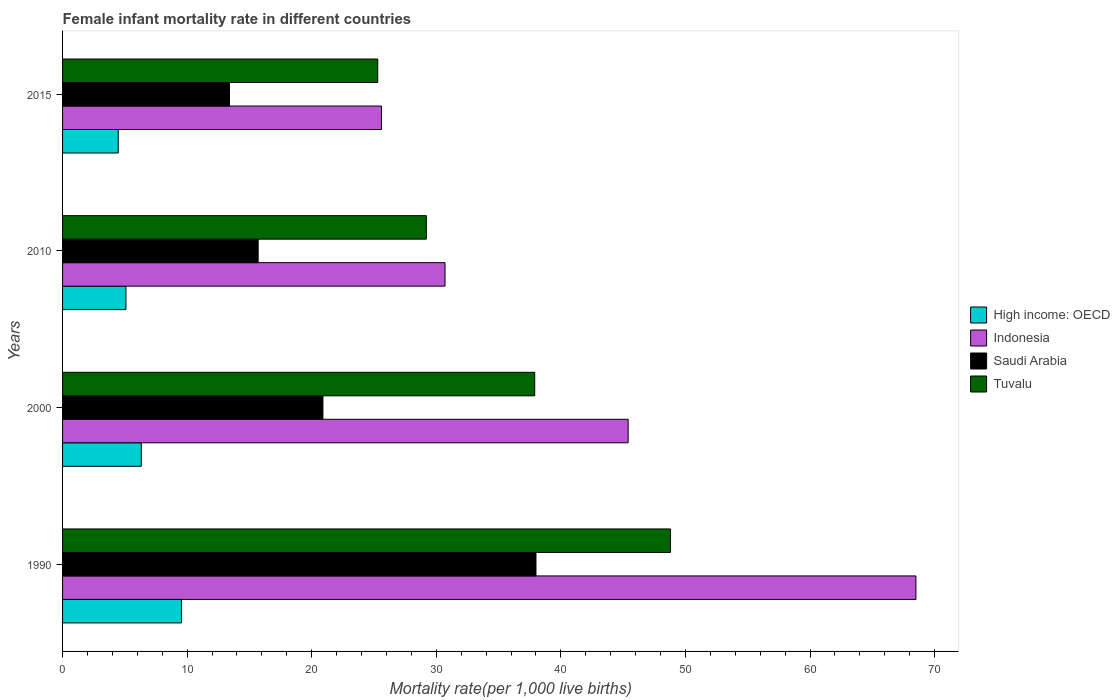How many groups of bars are there?
Ensure brevity in your answer.  4. Are the number of bars on each tick of the Y-axis equal?
Offer a very short reply. Yes. How many bars are there on the 1st tick from the bottom?
Your answer should be compact. 4. What is the label of the 3rd group of bars from the top?
Give a very brief answer. 2000. What is the female infant mortality rate in High income: OECD in 2010?
Your response must be concise. 5.09. Across all years, what is the maximum female infant mortality rate in Tuvalu?
Provide a succinct answer. 48.8. Across all years, what is the minimum female infant mortality rate in Indonesia?
Offer a terse response. 25.6. In which year was the female infant mortality rate in Tuvalu maximum?
Provide a short and direct response. 1990. In which year was the female infant mortality rate in Saudi Arabia minimum?
Ensure brevity in your answer.  2015. What is the difference between the female infant mortality rate in Saudi Arabia in 1990 and that in 2010?
Your response must be concise. 22.3. What is the difference between the female infant mortality rate in Indonesia in 2010 and the female infant mortality rate in High income: OECD in 2015?
Your answer should be very brief. 26.23. What is the average female infant mortality rate in High income: OECD per year?
Your answer should be very brief. 6.36. In the year 2015, what is the difference between the female infant mortality rate in Indonesia and female infant mortality rate in Saudi Arabia?
Your answer should be very brief. 12.2. In how many years, is the female infant mortality rate in High income: OECD greater than 56 ?
Provide a short and direct response. 0. What is the ratio of the female infant mortality rate in High income: OECD in 2000 to that in 2015?
Offer a terse response. 1.41. Is the female infant mortality rate in Tuvalu in 2000 less than that in 2010?
Keep it short and to the point. No. Is the difference between the female infant mortality rate in Indonesia in 1990 and 2000 greater than the difference between the female infant mortality rate in Saudi Arabia in 1990 and 2000?
Keep it short and to the point. Yes. What is the difference between the highest and the second highest female infant mortality rate in Indonesia?
Keep it short and to the point. 23.1. What is the difference between the highest and the lowest female infant mortality rate in High income: OECD?
Make the answer very short. 5.07. What does the 4th bar from the top in 2015 represents?
Offer a very short reply. High income: OECD. What does the 3rd bar from the bottom in 2000 represents?
Make the answer very short. Saudi Arabia. How many bars are there?
Ensure brevity in your answer.  16. Does the graph contain any zero values?
Provide a succinct answer. No. Where does the legend appear in the graph?
Your response must be concise. Center right. How are the legend labels stacked?
Offer a very short reply. Vertical. What is the title of the graph?
Your answer should be very brief. Female infant mortality rate in different countries. What is the label or title of the X-axis?
Provide a short and direct response. Mortality rate(per 1,0 live births). What is the label or title of the Y-axis?
Ensure brevity in your answer.  Years. What is the Mortality rate(per 1,000 live births) of High income: OECD in 1990?
Your response must be concise. 9.54. What is the Mortality rate(per 1,000 live births) in Indonesia in 1990?
Your answer should be compact. 68.5. What is the Mortality rate(per 1,000 live births) of Saudi Arabia in 1990?
Your answer should be very brief. 38. What is the Mortality rate(per 1,000 live births) in Tuvalu in 1990?
Keep it short and to the point. 48.8. What is the Mortality rate(per 1,000 live births) of High income: OECD in 2000?
Your answer should be compact. 6.32. What is the Mortality rate(per 1,000 live births) in Indonesia in 2000?
Your answer should be very brief. 45.4. What is the Mortality rate(per 1,000 live births) of Saudi Arabia in 2000?
Your response must be concise. 20.9. What is the Mortality rate(per 1,000 live births) in Tuvalu in 2000?
Give a very brief answer. 37.9. What is the Mortality rate(per 1,000 live births) in High income: OECD in 2010?
Offer a very short reply. 5.09. What is the Mortality rate(per 1,000 live births) of Indonesia in 2010?
Offer a terse response. 30.7. What is the Mortality rate(per 1,000 live births) of Tuvalu in 2010?
Your response must be concise. 29.2. What is the Mortality rate(per 1,000 live births) of High income: OECD in 2015?
Your answer should be very brief. 4.47. What is the Mortality rate(per 1,000 live births) in Indonesia in 2015?
Provide a short and direct response. 25.6. What is the Mortality rate(per 1,000 live births) in Saudi Arabia in 2015?
Keep it short and to the point. 13.4. What is the Mortality rate(per 1,000 live births) in Tuvalu in 2015?
Your answer should be compact. 25.3. Across all years, what is the maximum Mortality rate(per 1,000 live births) of High income: OECD?
Give a very brief answer. 9.54. Across all years, what is the maximum Mortality rate(per 1,000 live births) of Indonesia?
Offer a terse response. 68.5. Across all years, what is the maximum Mortality rate(per 1,000 live births) in Saudi Arabia?
Provide a short and direct response. 38. Across all years, what is the maximum Mortality rate(per 1,000 live births) of Tuvalu?
Offer a terse response. 48.8. Across all years, what is the minimum Mortality rate(per 1,000 live births) of High income: OECD?
Your answer should be very brief. 4.47. Across all years, what is the minimum Mortality rate(per 1,000 live births) in Indonesia?
Provide a short and direct response. 25.6. Across all years, what is the minimum Mortality rate(per 1,000 live births) in Tuvalu?
Provide a succinct answer. 25.3. What is the total Mortality rate(per 1,000 live births) in High income: OECD in the graph?
Your answer should be very brief. 25.42. What is the total Mortality rate(per 1,000 live births) in Indonesia in the graph?
Give a very brief answer. 170.2. What is the total Mortality rate(per 1,000 live births) of Tuvalu in the graph?
Offer a terse response. 141.2. What is the difference between the Mortality rate(per 1,000 live births) of High income: OECD in 1990 and that in 2000?
Your answer should be compact. 3.22. What is the difference between the Mortality rate(per 1,000 live births) in Indonesia in 1990 and that in 2000?
Your answer should be very brief. 23.1. What is the difference between the Mortality rate(per 1,000 live births) in High income: OECD in 1990 and that in 2010?
Provide a short and direct response. 4.45. What is the difference between the Mortality rate(per 1,000 live births) in Indonesia in 1990 and that in 2010?
Ensure brevity in your answer.  37.8. What is the difference between the Mortality rate(per 1,000 live births) in Saudi Arabia in 1990 and that in 2010?
Your response must be concise. 22.3. What is the difference between the Mortality rate(per 1,000 live births) in Tuvalu in 1990 and that in 2010?
Give a very brief answer. 19.6. What is the difference between the Mortality rate(per 1,000 live births) in High income: OECD in 1990 and that in 2015?
Keep it short and to the point. 5.07. What is the difference between the Mortality rate(per 1,000 live births) of Indonesia in 1990 and that in 2015?
Offer a very short reply. 42.9. What is the difference between the Mortality rate(per 1,000 live births) of Saudi Arabia in 1990 and that in 2015?
Keep it short and to the point. 24.6. What is the difference between the Mortality rate(per 1,000 live births) of High income: OECD in 2000 and that in 2010?
Your answer should be very brief. 1.23. What is the difference between the Mortality rate(per 1,000 live births) of Tuvalu in 2000 and that in 2010?
Make the answer very short. 8.7. What is the difference between the Mortality rate(per 1,000 live births) in High income: OECD in 2000 and that in 2015?
Your answer should be very brief. 1.85. What is the difference between the Mortality rate(per 1,000 live births) of Indonesia in 2000 and that in 2015?
Your answer should be very brief. 19.8. What is the difference between the Mortality rate(per 1,000 live births) of Saudi Arabia in 2000 and that in 2015?
Your response must be concise. 7.5. What is the difference between the Mortality rate(per 1,000 live births) in Tuvalu in 2000 and that in 2015?
Offer a terse response. 12.6. What is the difference between the Mortality rate(per 1,000 live births) in High income: OECD in 2010 and that in 2015?
Give a very brief answer. 0.62. What is the difference between the Mortality rate(per 1,000 live births) of Tuvalu in 2010 and that in 2015?
Keep it short and to the point. 3.9. What is the difference between the Mortality rate(per 1,000 live births) of High income: OECD in 1990 and the Mortality rate(per 1,000 live births) of Indonesia in 2000?
Offer a very short reply. -35.86. What is the difference between the Mortality rate(per 1,000 live births) in High income: OECD in 1990 and the Mortality rate(per 1,000 live births) in Saudi Arabia in 2000?
Offer a very short reply. -11.36. What is the difference between the Mortality rate(per 1,000 live births) in High income: OECD in 1990 and the Mortality rate(per 1,000 live births) in Tuvalu in 2000?
Keep it short and to the point. -28.36. What is the difference between the Mortality rate(per 1,000 live births) of Indonesia in 1990 and the Mortality rate(per 1,000 live births) of Saudi Arabia in 2000?
Keep it short and to the point. 47.6. What is the difference between the Mortality rate(per 1,000 live births) in Indonesia in 1990 and the Mortality rate(per 1,000 live births) in Tuvalu in 2000?
Your answer should be very brief. 30.6. What is the difference between the Mortality rate(per 1,000 live births) in High income: OECD in 1990 and the Mortality rate(per 1,000 live births) in Indonesia in 2010?
Provide a succinct answer. -21.16. What is the difference between the Mortality rate(per 1,000 live births) of High income: OECD in 1990 and the Mortality rate(per 1,000 live births) of Saudi Arabia in 2010?
Keep it short and to the point. -6.16. What is the difference between the Mortality rate(per 1,000 live births) of High income: OECD in 1990 and the Mortality rate(per 1,000 live births) of Tuvalu in 2010?
Your answer should be compact. -19.66. What is the difference between the Mortality rate(per 1,000 live births) in Indonesia in 1990 and the Mortality rate(per 1,000 live births) in Saudi Arabia in 2010?
Your answer should be very brief. 52.8. What is the difference between the Mortality rate(per 1,000 live births) in Indonesia in 1990 and the Mortality rate(per 1,000 live births) in Tuvalu in 2010?
Offer a terse response. 39.3. What is the difference between the Mortality rate(per 1,000 live births) of Saudi Arabia in 1990 and the Mortality rate(per 1,000 live births) of Tuvalu in 2010?
Offer a terse response. 8.8. What is the difference between the Mortality rate(per 1,000 live births) of High income: OECD in 1990 and the Mortality rate(per 1,000 live births) of Indonesia in 2015?
Offer a very short reply. -16.06. What is the difference between the Mortality rate(per 1,000 live births) in High income: OECD in 1990 and the Mortality rate(per 1,000 live births) in Saudi Arabia in 2015?
Offer a very short reply. -3.86. What is the difference between the Mortality rate(per 1,000 live births) of High income: OECD in 1990 and the Mortality rate(per 1,000 live births) of Tuvalu in 2015?
Ensure brevity in your answer.  -15.76. What is the difference between the Mortality rate(per 1,000 live births) in Indonesia in 1990 and the Mortality rate(per 1,000 live births) in Saudi Arabia in 2015?
Make the answer very short. 55.1. What is the difference between the Mortality rate(per 1,000 live births) in Indonesia in 1990 and the Mortality rate(per 1,000 live births) in Tuvalu in 2015?
Ensure brevity in your answer.  43.2. What is the difference between the Mortality rate(per 1,000 live births) in High income: OECD in 2000 and the Mortality rate(per 1,000 live births) in Indonesia in 2010?
Provide a succinct answer. -24.38. What is the difference between the Mortality rate(per 1,000 live births) of High income: OECD in 2000 and the Mortality rate(per 1,000 live births) of Saudi Arabia in 2010?
Offer a terse response. -9.38. What is the difference between the Mortality rate(per 1,000 live births) in High income: OECD in 2000 and the Mortality rate(per 1,000 live births) in Tuvalu in 2010?
Offer a very short reply. -22.88. What is the difference between the Mortality rate(per 1,000 live births) in Indonesia in 2000 and the Mortality rate(per 1,000 live births) in Saudi Arabia in 2010?
Keep it short and to the point. 29.7. What is the difference between the Mortality rate(per 1,000 live births) of High income: OECD in 2000 and the Mortality rate(per 1,000 live births) of Indonesia in 2015?
Keep it short and to the point. -19.28. What is the difference between the Mortality rate(per 1,000 live births) of High income: OECD in 2000 and the Mortality rate(per 1,000 live births) of Saudi Arabia in 2015?
Make the answer very short. -7.08. What is the difference between the Mortality rate(per 1,000 live births) in High income: OECD in 2000 and the Mortality rate(per 1,000 live births) in Tuvalu in 2015?
Your answer should be compact. -18.98. What is the difference between the Mortality rate(per 1,000 live births) of Indonesia in 2000 and the Mortality rate(per 1,000 live births) of Saudi Arabia in 2015?
Provide a succinct answer. 32. What is the difference between the Mortality rate(per 1,000 live births) of Indonesia in 2000 and the Mortality rate(per 1,000 live births) of Tuvalu in 2015?
Offer a very short reply. 20.1. What is the difference between the Mortality rate(per 1,000 live births) in Saudi Arabia in 2000 and the Mortality rate(per 1,000 live births) in Tuvalu in 2015?
Offer a terse response. -4.4. What is the difference between the Mortality rate(per 1,000 live births) in High income: OECD in 2010 and the Mortality rate(per 1,000 live births) in Indonesia in 2015?
Offer a very short reply. -20.51. What is the difference between the Mortality rate(per 1,000 live births) in High income: OECD in 2010 and the Mortality rate(per 1,000 live births) in Saudi Arabia in 2015?
Your answer should be very brief. -8.31. What is the difference between the Mortality rate(per 1,000 live births) of High income: OECD in 2010 and the Mortality rate(per 1,000 live births) of Tuvalu in 2015?
Provide a succinct answer. -20.21. What is the difference between the Mortality rate(per 1,000 live births) of Indonesia in 2010 and the Mortality rate(per 1,000 live births) of Tuvalu in 2015?
Your answer should be compact. 5.4. What is the difference between the Mortality rate(per 1,000 live births) of Saudi Arabia in 2010 and the Mortality rate(per 1,000 live births) of Tuvalu in 2015?
Provide a short and direct response. -9.6. What is the average Mortality rate(per 1,000 live births) of High income: OECD per year?
Keep it short and to the point. 6.36. What is the average Mortality rate(per 1,000 live births) of Indonesia per year?
Ensure brevity in your answer.  42.55. What is the average Mortality rate(per 1,000 live births) of Tuvalu per year?
Offer a terse response. 35.3. In the year 1990, what is the difference between the Mortality rate(per 1,000 live births) in High income: OECD and Mortality rate(per 1,000 live births) in Indonesia?
Keep it short and to the point. -58.96. In the year 1990, what is the difference between the Mortality rate(per 1,000 live births) in High income: OECD and Mortality rate(per 1,000 live births) in Saudi Arabia?
Your answer should be compact. -28.46. In the year 1990, what is the difference between the Mortality rate(per 1,000 live births) in High income: OECD and Mortality rate(per 1,000 live births) in Tuvalu?
Offer a very short reply. -39.26. In the year 1990, what is the difference between the Mortality rate(per 1,000 live births) of Indonesia and Mortality rate(per 1,000 live births) of Saudi Arabia?
Your answer should be very brief. 30.5. In the year 1990, what is the difference between the Mortality rate(per 1,000 live births) of Saudi Arabia and Mortality rate(per 1,000 live births) of Tuvalu?
Ensure brevity in your answer.  -10.8. In the year 2000, what is the difference between the Mortality rate(per 1,000 live births) in High income: OECD and Mortality rate(per 1,000 live births) in Indonesia?
Ensure brevity in your answer.  -39.08. In the year 2000, what is the difference between the Mortality rate(per 1,000 live births) of High income: OECD and Mortality rate(per 1,000 live births) of Saudi Arabia?
Provide a succinct answer. -14.58. In the year 2000, what is the difference between the Mortality rate(per 1,000 live births) of High income: OECD and Mortality rate(per 1,000 live births) of Tuvalu?
Give a very brief answer. -31.58. In the year 2000, what is the difference between the Mortality rate(per 1,000 live births) in Indonesia and Mortality rate(per 1,000 live births) in Saudi Arabia?
Your answer should be compact. 24.5. In the year 2000, what is the difference between the Mortality rate(per 1,000 live births) in Indonesia and Mortality rate(per 1,000 live births) in Tuvalu?
Keep it short and to the point. 7.5. In the year 2010, what is the difference between the Mortality rate(per 1,000 live births) of High income: OECD and Mortality rate(per 1,000 live births) of Indonesia?
Your answer should be very brief. -25.61. In the year 2010, what is the difference between the Mortality rate(per 1,000 live births) in High income: OECD and Mortality rate(per 1,000 live births) in Saudi Arabia?
Ensure brevity in your answer.  -10.61. In the year 2010, what is the difference between the Mortality rate(per 1,000 live births) of High income: OECD and Mortality rate(per 1,000 live births) of Tuvalu?
Your answer should be compact. -24.11. In the year 2010, what is the difference between the Mortality rate(per 1,000 live births) in Indonesia and Mortality rate(per 1,000 live births) in Tuvalu?
Offer a very short reply. 1.5. In the year 2015, what is the difference between the Mortality rate(per 1,000 live births) in High income: OECD and Mortality rate(per 1,000 live births) in Indonesia?
Ensure brevity in your answer.  -21.13. In the year 2015, what is the difference between the Mortality rate(per 1,000 live births) of High income: OECD and Mortality rate(per 1,000 live births) of Saudi Arabia?
Ensure brevity in your answer.  -8.93. In the year 2015, what is the difference between the Mortality rate(per 1,000 live births) of High income: OECD and Mortality rate(per 1,000 live births) of Tuvalu?
Your answer should be very brief. -20.83. In the year 2015, what is the difference between the Mortality rate(per 1,000 live births) in Indonesia and Mortality rate(per 1,000 live births) in Tuvalu?
Your answer should be very brief. 0.3. In the year 2015, what is the difference between the Mortality rate(per 1,000 live births) of Saudi Arabia and Mortality rate(per 1,000 live births) of Tuvalu?
Provide a short and direct response. -11.9. What is the ratio of the Mortality rate(per 1,000 live births) of High income: OECD in 1990 to that in 2000?
Make the answer very short. 1.51. What is the ratio of the Mortality rate(per 1,000 live births) in Indonesia in 1990 to that in 2000?
Your answer should be very brief. 1.51. What is the ratio of the Mortality rate(per 1,000 live births) in Saudi Arabia in 1990 to that in 2000?
Make the answer very short. 1.82. What is the ratio of the Mortality rate(per 1,000 live births) of Tuvalu in 1990 to that in 2000?
Provide a succinct answer. 1.29. What is the ratio of the Mortality rate(per 1,000 live births) of High income: OECD in 1990 to that in 2010?
Ensure brevity in your answer.  1.88. What is the ratio of the Mortality rate(per 1,000 live births) of Indonesia in 1990 to that in 2010?
Your answer should be compact. 2.23. What is the ratio of the Mortality rate(per 1,000 live births) in Saudi Arabia in 1990 to that in 2010?
Make the answer very short. 2.42. What is the ratio of the Mortality rate(per 1,000 live births) in Tuvalu in 1990 to that in 2010?
Ensure brevity in your answer.  1.67. What is the ratio of the Mortality rate(per 1,000 live births) in High income: OECD in 1990 to that in 2015?
Make the answer very short. 2.13. What is the ratio of the Mortality rate(per 1,000 live births) in Indonesia in 1990 to that in 2015?
Your response must be concise. 2.68. What is the ratio of the Mortality rate(per 1,000 live births) in Saudi Arabia in 1990 to that in 2015?
Provide a succinct answer. 2.84. What is the ratio of the Mortality rate(per 1,000 live births) of Tuvalu in 1990 to that in 2015?
Provide a short and direct response. 1.93. What is the ratio of the Mortality rate(per 1,000 live births) in High income: OECD in 2000 to that in 2010?
Provide a short and direct response. 1.24. What is the ratio of the Mortality rate(per 1,000 live births) in Indonesia in 2000 to that in 2010?
Make the answer very short. 1.48. What is the ratio of the Mortality rate(per 1,000 live births) in Saudi Arabia in 2000 to that in 2010?
Make the answer very short. 1.33. What is the ratio of the Mortality rate(per 1,000 live births) in Tuvalu in 2000 to that in 2010?
Your response must be concise. 1.3. What is the ratio of the Mortality rate(per 1,000 live births) in High income: OECD in 2000 to that in 2015?
Your answer should be very brief. 1.41. What is the ratio of the Mortality rate(per 1,000 live births) of Indonesia in 2000 to that in 2015?
Offer a terse response. 1.77. What is the ratio of the Mortality rate(per 1,000 live births) of Saudi Arabia in 2000 to that in 2015?
Your answer should be compact. 1.56. What is the ratio of the Mortality rate(per 1,000 live births) in Tuvalu in 2000 to that in 2015?
Offer a terse response. 1.5. What is the ratio of the Mortality rate(per 1,000 live births) in High income: OECD in 2010 to that in 2015?
Keep it short and to the point. 1.14. What is the ratio of the Mortality rate(per 1,000 live births) of Indonesia in 2010 to that in 2015?
Keep it short and to the point. 1.2. What is the ratio of the Mortality rate(per 1,000 live births) of Saudi Arabia in 2010 to that in 2015?
Provide a succinct answer. 1.17. What is the ratio of the Mortality rate(per 1,000 live births) in Tuvalu in 2010 to that in 2015?
Your response must be concise. 1.15. What is the difference between the highest and the second highest Mortality rate(per 1,000 live births) of High income: OECD?
Your answer should be compact. 3.22. What is the difference between the highest and the second highest Mortality rate(per 1,000 live births) in Indonesia?
Your answer should be compact. 23.1. What is the difference between the highest and the lowest Mortality rate(per 1,000 live births) in High income: OECD?
Keep it short and to the point. 5.07. What is the difference between the highest and the lowest Mortality rate(per 1,000 live births) of Indonesia?
Offer a terse response. 42.9. What is the difference between the highest and the lowest Mortality rate(per 1,000 live births) of Saudi Arabia?
Your response must be concise. 24.6. What is the difference between the highest and the lowest Mortality rate(per 1,000 live births) of Tuvalu?
Provide a short and direct response. 23.5. 